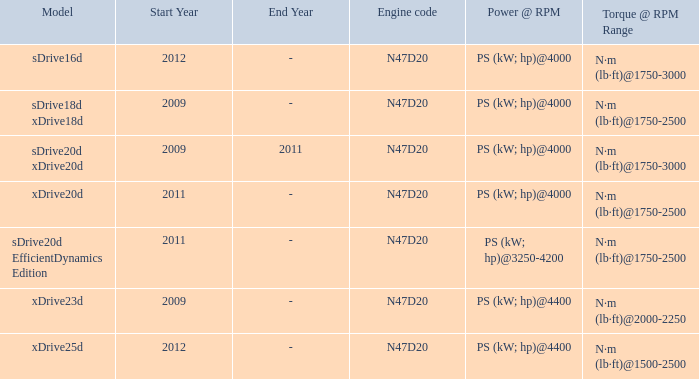Help me parse the entirety of this table. {'header': ['Model', 'Start Year', 'End Year', 'Engine code', 'Power @ RPM', 'Torque @ RPM Range'], 'rows': [['sDrive16d', '2012', '-', 'N47D20', 'PS (kW; hp)@4000', 'N·m (lb·ft)@1750-3000'], ['sDrive18d xDrive18d', '2009', '-', 'N47D20', 'PS (kW; hp)@4000', 'N·m (lb·ft)@1750-2500'], ['sDrive20d xDrive20d', '2009', '2011', 'N47D20', 'PS (kW; hp)@4000', 'N·m (lb·ft)@1750-3000'], ['xDrive20d', '2011', '-', 'N47D20', 'PS (kW; hp)@4000', 'N·m (lb·ft)@1750-2500'], ['sDrive20d EfficientDynamics Edition', '2011', '-', 'N47D20', 'PS (kW; hp)@3250-4200', 'N·m (lb·ft)@1750-2500'], ['xDrive23d', '2009', '-', 'N47D20', 'PS (kW; hp)@4400', 'N·m (lb·ft)@2000-2250'], ['xDrive25d', '2012', '-', 'N47D20', 'PS (kW; hp)@4400', 'N·m (lb·ft)@1500-2500']]} What model is the n·m (lb·ft)@1500-2500 torque? Xdrive25d. 